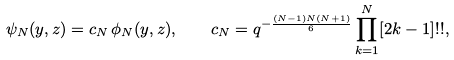<formula> <loc_0><loc_0><loc_500><loc_500>\psi _ { N } ( y , z ) = c _ { N } \, \phi _ { N } ( y , z ) , \quad c _ { N } = q ^ { - \frac { ( N - 1 ) N ( N + 1 ) } { 6 } } \prod _ { k = 1 } ^ { N } [ 2 k - 1 ] ! ! ,</formula> 